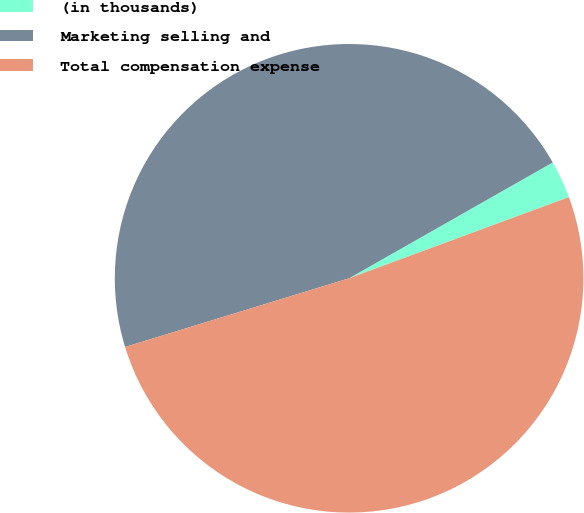Convert chart to OTSL. <chart><loc_0><loc_0><loc_500><loc_500><pie_chart><fcel>(in thousands)<fcel>Marketing selling and<fcel>Total compensation expense<nl><fcel>2.6%<fcel>46.51%<fcel>50.9%<nl></chart> 